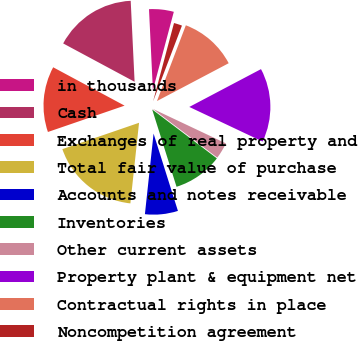<chart> <loc_0><loc_0><loc_500><loc_500><pie_chart><fcel>in thousands<fcel>Cash<fcel>Exchanges of real property and<fcel>Total fair value of purchase<fcel>Accounts and notes receivable<fcel>Inventories<fcel>Other current assets<fcel>Property plant & equipment net<fcel>Contractual rights in place<fcel>Noncompetition agreement<nl><fcel>4.92%<fcel>16.39%<fcel>13.11%<fcel>18.03%<fcel>6.56%<fcel>9.84%<fcel>3.28%<fcel>14.75%<fcel>11.48%<fcel>1.64%<nl></chart> 